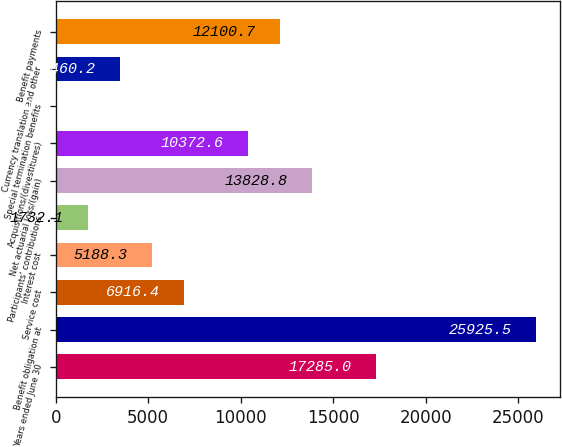Convert chart to OTSL. <chart><loc_0><loc_0><loc_500><loc_500><bar_chart><fcel>Years ended June 30<fcel>Benefit obligation at<fcel>Service cost<fcel>Interest cost<fcel>Participants' contributions<fcel>Net actuarial loss/(gain)<fcel>Acquisitions/(divestitures)<fcel>Special termination benefits<fcel>Currency translation and other<fcel>Benefit payments<nl><fcel>17285<fcel>25925.5<fcel>6916.4<fcel>5188.3<fcel>1732.1<fcel>13828.8<fcel>10372.6<fcel>4<fcel>3460.2<fcel>12100.7<nl></chart> 